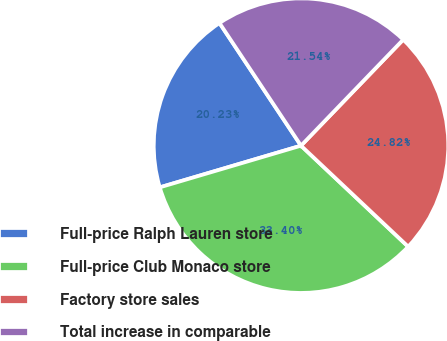Convert chart. <chart><loc_0><loc_0><loc_500><loc_500><pie_chart><fcel>Full-price Ralph Lauren store<fcel>Full-price Club Monaco store<fcel>Factory store sales<fcel>Total increase in comparable<nl><fcel>20.23%<fcel>33.4%<fcel>24.82%<fcel>21.54%<nl></chart> 